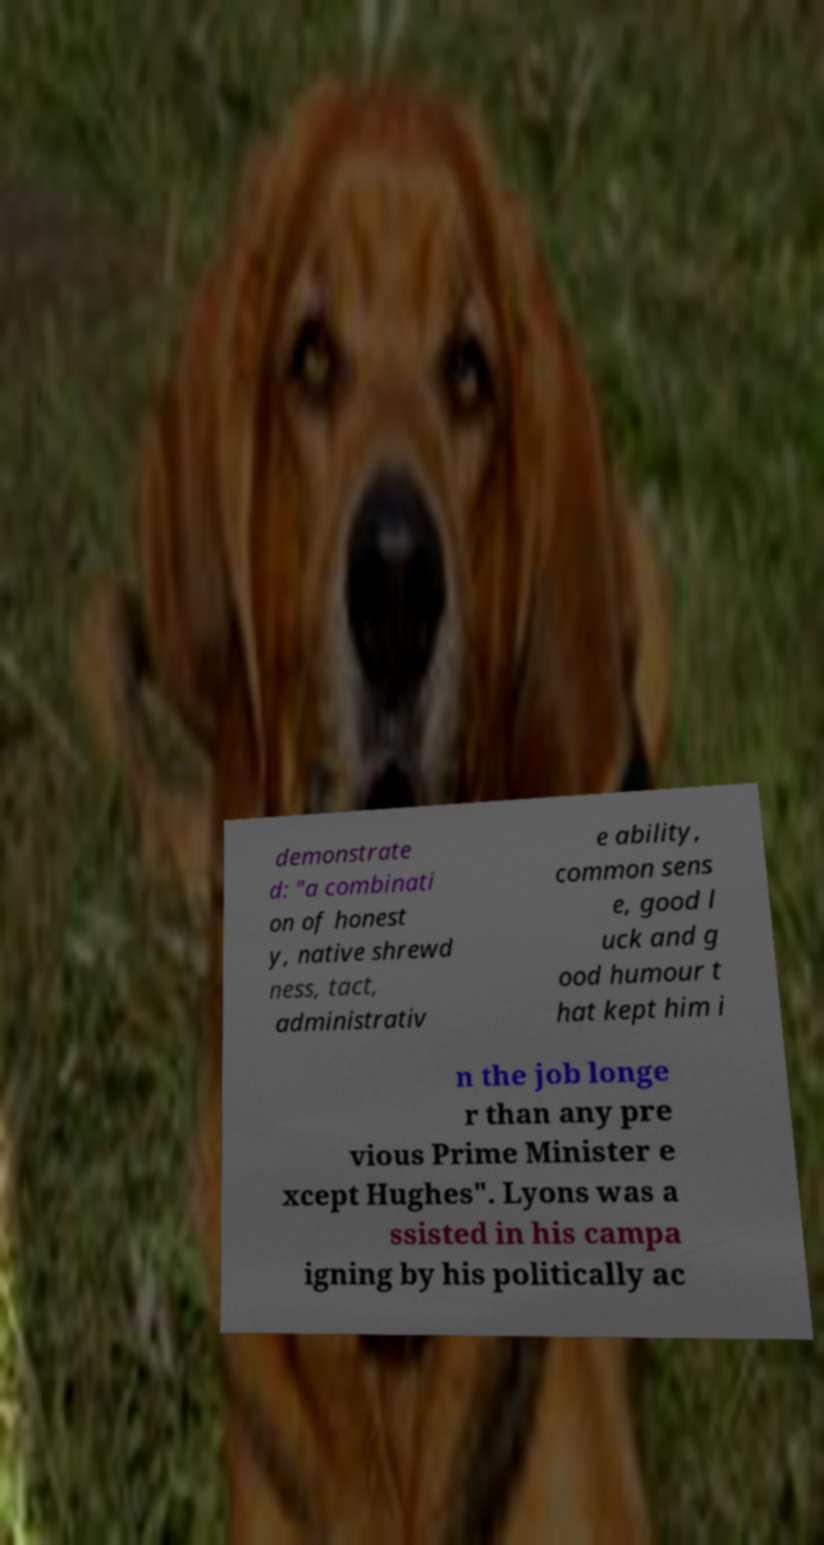Can you read and provide the text displayed in the image?This photo seems to have some interesting text. Can you extract and type it out for me? demonstrate d: "a combinati on of honest y, native shrewd ness, tact, administrativ e ability, common sens e, good l uck and g ood humour t hat kept him i n the job longe r than any pre vious Prime Minister e xcept Hughes". Lyons was a ssisted in his campa igning by his politically ac 